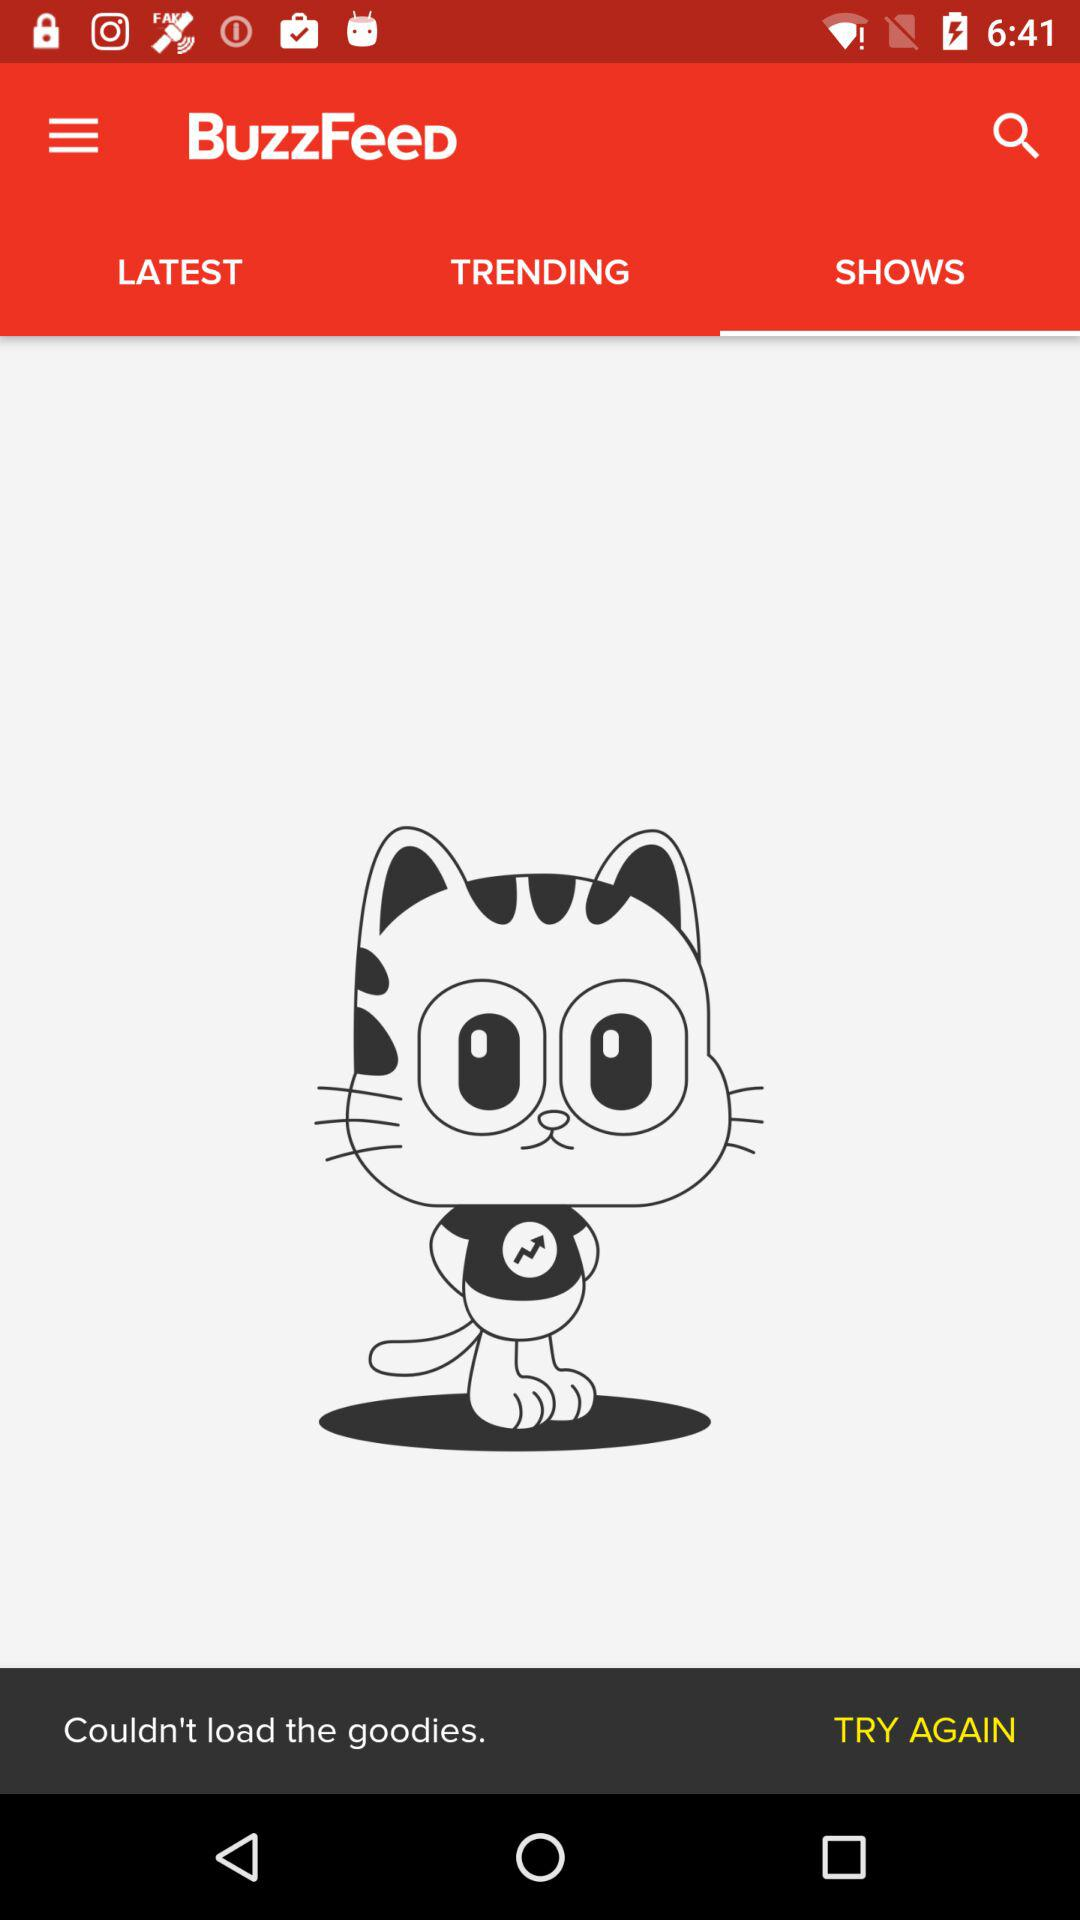Which tab has been selected? The tab "SHOWS" has been selected. 